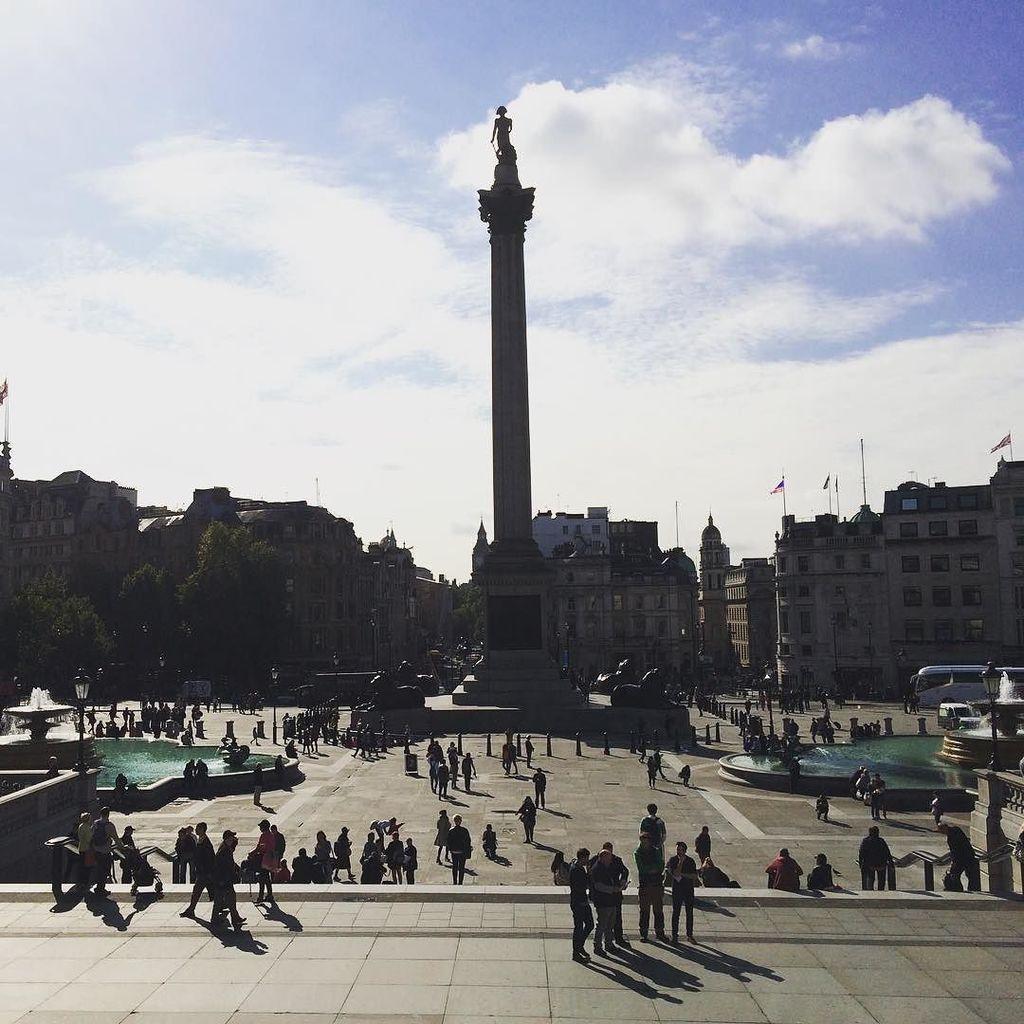Describe this image in one or two sentences. In this picture we can observe some people standing. Some of them were walking and some of them were sitting. There is a tall pillar and there is a statue on this pillar. We can observe fountains on either sides of this image. There are trees and buildings. We can observe a bus on the right side. In the background there is a sky with clouds. 